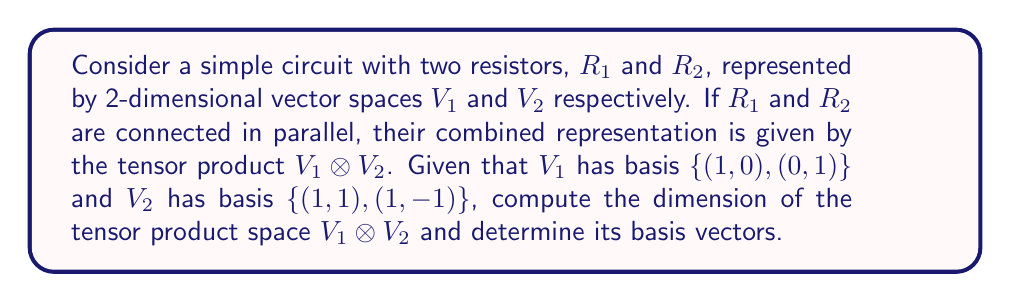Show me your answer to this math problem. To solve this problem, we'll follow these steps:

1) First, recall that for two vector spaces $V$ and $W$ with dimensions $m$ and $n$ respectively, the dimension of their tensor product $V \otimes W$ is $mn$.

2) In our case, $\dim(V_1) = 2$ and $\dim(V_2) = 2$. Therefore:

   $\dim(V_1 \otimes V_2) = \dim(V_1) \cdot \dim(V_2) = 2 \cdot 2 = 4$

3) To find the basis of $V_1 \otimes V_2$, we need to take the tensor product of each basis vector of $V_1$ with each basis vector of $V_2$:

   Let $v_1 = (1,0)$, $v_2 = (0,1)$ be the basis vectors of $V_1$
   Let $w_1 = (1,1)$, $w_2 = (1,-1)$ be the basis vectors of $V_2$

4) The basis vectors of $V_1 \otimes V_2$ are:

   $v_1 \otimes w_1 = (1,0) \otimes (1,1) = (1,1,0,0)$
   $v_1 \otimes w_2 = (1,0) \otimes (1,-1) = (1,-1,0,0)$
   $v_2 \otimes w_1 = (0,1) \otimes (1,1) = (0,0,1,1)$
   $v_2 \otimes w_2 = (0,1) \otimes (1,-1) = (0,0,1,-1)$

5) These four 4-dimensional vectors form the basis of $V_1 \otimes V_2$.
Answer: $\dim(V_1 \otimes V_2) = 4$, Basis: $\{(1,1,0,0), (1,-1,0,0), (0,0,1,1), (0,0,1,-1)\}$ 